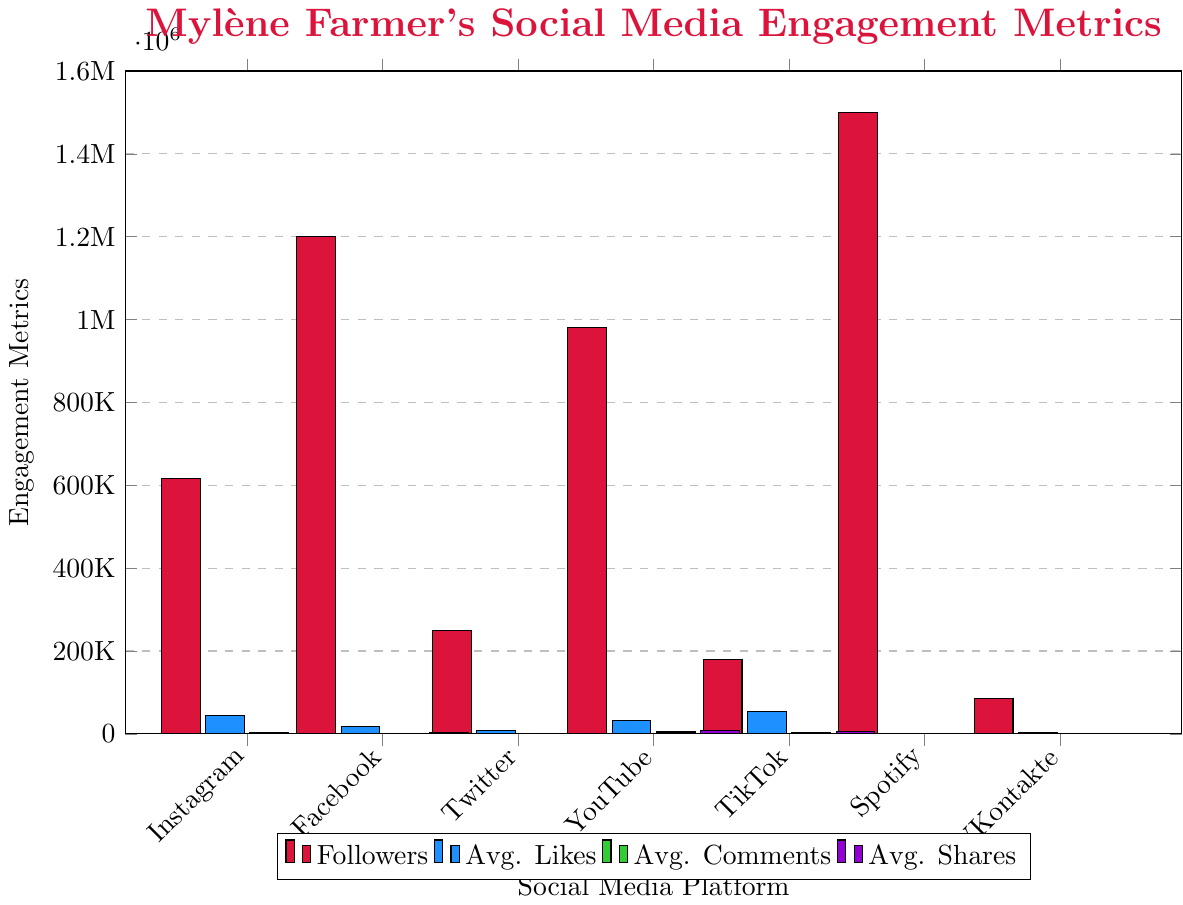Which platform has the highest number of followers? Observing the chart, Spotify has the tallest red bar, indicating it has the highest number of followers.
Answer: Spotify Which platform receives the most average likes? By comparing the blue bars, the tallest one corresponds to TikTok, indicating it receives the most average likes.
Answer: TikTok Which platform has the lowest average comments? Among the green bars, the shortest one is for Twitter, indicating it has the lowest average comments.
Answer: Twitter How does the number of followers on Facebook compare to YouTube? Comparing the red bars for Facebook and YouTube, the Facebook bar is taller, indicating Facebook has more followers than YouTube.
Answer: Facebook has more followers What is the total number of followers across all platforms? Sum the heights of all red bars: 617,000 (Instagram) + 1,200,000 (Facebook) + 250,000 (Twitter) + 980,000 (YouTube) + 180,000 (TikTok) + 1,500,000 (Spotify) + 85,000 (VKontakte) = 4,812,000
Answer: 4,812,000 Which platform has the highest engagement in terms of average shares? By comparing the purple bars, YouTube's bar is the tallest, indicating it has the most average shares.
Answer: YouTube What is the difference in the number of followers between the platform with the highest followers and the one with the lowest? Spotify has the highest followers (1,500,000) and VKontakte has the lowest (85,000). The difference is 1,500,000 - 85,000 = 1,415,000
Answer: 1,415,000 How many platforms have more than 1,000,000 followers? Observing the red bars, three platforms (Facebook, YouTube, Spotify) have bars reaching above the 1,000,000 mark.
Answer: Three Which platform has higher average comments, TikTok or Instagram? Comparing the green bars for TikTok and Instagram, TikTok's bar is taller, indicating it has higher average comments than Instagram.
Answer: TikTok What is the total average likes for Instagram, Facebook, and Twitter combined? For Instagram, Facebook, and Twitter, the average likes are 45,000, 18,000, and 8,000 respectively. Summing these gives 45,000 + 18,000 + 8,000 = 71,000.
Answer: 71,000 